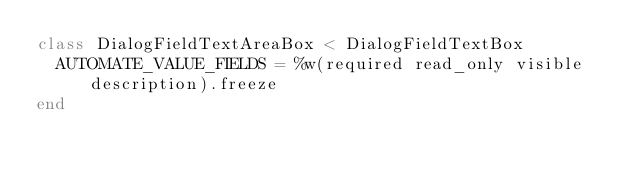Convert code to text. <code><loc_0><loc_0><loc_500><loc_500><_Ruby_>class DialogFieldTextAreaBox < DialogFieldTextBox
  AUTOMATE_VALUE_FIELDS = %w(required read_only visible description).freeze
end
</code> 